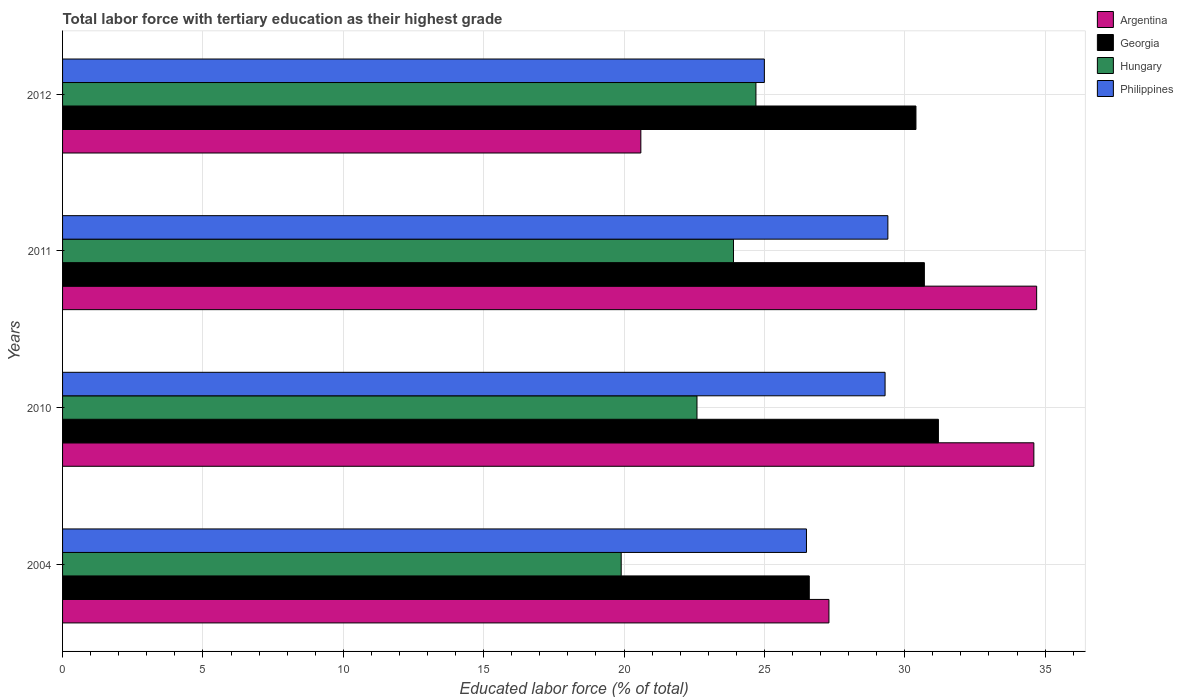How many groups of bars are there?
Your response must be concise. 4. Are the number of bars per tick equal to the number of legend labels?
Keep it short and to the point. Yes. Are the number of bars on each tick of the Y-axis equal?
Your answer should be compact. Yes. How many bars are there on the 1st tick from the bottom?
Your answer should be very brief. 4. What is the label of the 3rd group of bars from the top?
Your answer should be very brief. 2010. In how many cases, is the number of bars for a given year not equal to the number of legend labels?
Make the answer very short. 0. What is the percentage of male labor force with tertiary education in Georgia in 2010?
Your response must be concise. 31.2. Across all years, what is the maximum percentage of male labor force with tertiary education in Hungary?
Ensure brevity in your answer.  24.7. Across all years, what is the minimum percentage of male labor force with tertiary education in Argentina?
Your answer should be very brief. 20.6. In which year was the percentage of male labor force with tertiary education in Georgia maximum?
Offer a terse response. 2010. What is the total percentage of male labor force with tertiary education in Hungary in the graph?
Your answer should be very brief. 91.1. What is the difference between the percentage of male labor force with tertiary education in Hungary in 2004 and that in 2011?
Ensure brevity in your answer.  -4. What is the difference between the percentage of male labor force with tertiary education in Georgia in 2011 and the percentage of male labor force with tertiary education in Philippines in 2012?
Offer a very short reply. 5.7. What is the average percentage of male labor force with tertiary education in Argentina per year?
Your answer should be very brief. 29.3. In the year 2010, what is the difference between the percentage of male labor force with tertiary education in Hungary and percentage of male labor force with tertiary education in Philippines?
Keep it short and to the point. -6.7. In how many years, is the percentage of male labor force with tertiary education in Hungary greater than 5 %?
Keep it short and to the point. 4. What is the ratio of the percentage of male labor force with tertiary education in Georgia in 2004 to that in 2012?
Give a very brief answer. 0.88. What is the difference between the highest and the second highest percentage of male labor force with tertiary education in Hungary?
Offer a terse response. 0.8. What is the difference between the highest and the lowest percentage of male labor force with tertiary education in Georgia?
Offer a terse response. 4.6. What does the 3rd bar from the top in 2010 represents?
Give a very brief answer. Georgia. What does the 2nd bar from the bottom in 2012 represents?
Your answer should be very brief. Georgia. Is it the case that in every year, the sum of the percentage of male labor force with tertiary education in Argentina and percentage of male labor force with tertiary education in Hungary is greater than the percentage of male labor force with tertiary education in Georgia?
Provide a succinct answer. Yes. What is the difference between two consecutive major ticks on the X-axis?
Make the answer very short. 5. Does the graph contain grids?
Offer a terse response. Yes. How many legend labels are there?
Your answer should be compact. 4. How are the legend labels stacked?
Your answer should be very brief. Vertical. What is the title of the graph?
Your answer should be compact. Total labor force with tertiary education as their highest grade. What is the label or title of the X-axis?
Provide a short and direct response. Educated labor force (% of total). What is the label or title of the Y-axis?
Make the answer very short. Years. What is the Educated labor force (% of total) of Argentina in 2004?
Keep it short and to the point. 27.3. What is the Educated labor force (% of total) in Georgia in 2004?
Make the answer very short. 26.6. What is the Educated labor force (% of total) of Hungary in 2004?
Give a very brief answer. 19.9. What is the Educated labor force (% of total) of Argentina in 2010?
Your answer should be compact. 34.6. What is the Educated labor force (% of total) of Georgia in 2010?
Offer a very short reply. 31.2. What is the Educated labor force (% of total) in Hungary in 2010?
Ensure brevity in your answer.  22.6. What is the Educated labor force (% of total) in Philippines in 2010?
Offer a very short reply. 29.3. What is the Educated labor force (% of total) in Argentina in 2011?
Your answer should be compact. 34.7. What is the Educated labor force (% of total) in Georgia in 2011?
Offer a very short reply. 30.7. What is the Educated labor force (% of total) in Hungary in 2011?
Your response must be concise. 23.9. What is the Educated labor force (% of total) in Philippines in 2011?
Keep it short and to the point. 29.4. What is the Educated labor force (% of total) of Argentina in 2012?
Provide a succinct answer. 20.6. What is the Educated labor force (% of total) in Georgia in 2012?
Provide a succinct answer. 30.4. What is the Educated labor force (% of total) in Hungary in 2012?
Your answer should be compact. 24.7. Across all years, what is the maximum Educated labor force (% of total) of Argentina?
Offer a terse response. 34.7. Across all years, what is the maximum Educated labor force (% of total) in Georgia?
Make the answer very short. 31.2. Across all years, what is the maximum Educated labor force (% of total) in Hungary?
Ensure brevity in your answer.  24.7. Across all years, what is the maximum Educated labor force (% of total) in Philippines?
Give a very brief answer. 29.4. Across all years, what is the minimum Educated labor force (% of total) of Argentina?
Provide a succinct answer. 20.6. Across all years, what is the minimum Educated labor force (% of total) in Georgia?
Keep it short and to the point. 26.6. Across all years, what is the minimum Educated labor force (% of total) of Hungary?
Provide a succinct answer. 19.9. Across all years, what is the minimum Educated labor force (% of total) of Philippines?
Offer a very short reply. 25. What is the total Educated labor force (% of total) in Argentina in the graph?
Keep it short and to the point. 117.2. What is the total Educated labor force (% of total) in Georgia in the graph?
Ensure brevity in your answer.  118.9. What is the total Educated labor force (% of total) in Hungary in the graph?
Ensure brevity in your answer.  91.1. What is the total Educated labor force (% of total) of Philippines in the graph?
Provide a short and direct response. 110.2. What is the difference between the Educated labor force (% of total) in Argentina in 2004 and that in 2010?
Offer a terse response. -7.3. What is the difference between the Educated labor force (% of total) of Georgia in 2004 and that in 2010?
Provide a succinct answer. -4.6. What is the difference between the Educated labor force (% of total) in Hungary in 2004 and that in 2010?
Provide a short and direct response. -2.7. What is the difference between the Educated labor force (% of total) of Philippines in 2004 and that in 2010?
Give a very brief answer. -2.8. What is the difference between the Educated labor force (% of total) in Argentina in 2004 and that in 2011?
Keep it short and to the point. -7.4. What is the difference between the Educated labor force (% of total) of Georgia in 2004 and that in 2012?
Offer a terse response. -3.8. What is the difference between the Educated labor force (% of total) of Hungary in 2004 and that in 2012?
Your response must be concise. -4.8. What is the difference between the Educated labor force (% of total) in Georgia in 2010 and that in 2011?
Make the answer very short. 0.5. What is the difference between the Educated labor force (% of total) of Georgia in 2010 and that in 2012?
Provide a succinct answer. 0.8. What is the difference between the Educated labor force (% of total) in Hungary in 2010 and that in 2012?
Offer a very short reply. -2.1. What is the difference between the Educated labor force (% of total) of Philippines in 2011 and that in 2012?
Your answer should be very brief. 4.4. What is the difference between the Educated labor force (% of total) of Georgia in 2004 and the Educated labor force (% of total) of Philippines in 2010?
Make the answer very short. -2.7. What is the difference between the Educated labor force (% of total) of Argentina in 2004 and the Educated labor force (% of total) of Georgia in 2011?
Offer a very short reply. -3.4. What is the difference between the Educated labor force (% of total) in Argentina in 2004 and the Educated labor force (% of total) in Hungary in 2011?
Your answer should be very brief. 3.4. What is the difference between the Educated labor force (% of total) in Argentina in 2004 and the Educated labor force (% of total) in Philippines in 2011?
Give a very brief answer. -2.1. What is the difference between the Educated labor force (% of total) of Georgia in 2004 and the Educated labor force (% of total) of Hungary in 2011?
Ensure brevity in your answer.  2.7. What is the difference between the Educated labor force (% of total) in Georgia in 2004 and the Educated labor force (% of total) in Philippines in 2011?
Keep it short and to the point. -2.8. What is the difference between the Educated labor force (% of total) in Georgia in 2004 and the Educated labor force (% of total) in Philippines in 2012?
Provide a succinct answer. 1.6. What is the difference between the Educated labor force (% of total) in Hungary in 2010 and the Educated labor force (% of total) in Philippines in 2011?
Give a very brief answer. -6.8. What is the difference between the Educated labor force (% of total) in Argentina in 2010 and the Educated labor force (% of total) in Georgia in 2012?
Keep it short and to the point. 4.2. What is the difference between the Educated labor force (% of total) of Argentina in 2010 and the Educated labor force (% of total) of Hungary in 2012?
Make the answer very short. 9.9. What is the difference between the Educated labor force (% of total) in Argentina in 2010 and the Educated labor force (% of total) in Philippines in 2012?
Offer a terse response. 9.6. What is the average Educated labor force (% of total) of Argentina per year?
Keep it short and to the point. 29.3. What is the average Educated labor force (% of total) in Georgia per year?
Your response must be concise. 29.73. What is the average Educated labor force (% of total) of Hungary per year?
Your answer should be compact. 22.77. What is the average Educated labor force (% of total) of Philippines per year?
Give a very brief answer. 27.55. In the year 2004, what is the difference between the Educated labor force (% of total) of Argentina and Educated labor force (% of total) of Hungary?
Keep it short and to the point. 7.4. In the year 2004, what is the difference between the Educated labor force (% of total) in Georgia and Educated labor force (% of total) in Philippines?
Offer a terse response. 0.1. In the year 2010, what is the difference between the Educated labor force (% of total) in Georgia and Educated labor force (% of total) in Philippines?
Make the answer very short. 1.9. In the year 2011, what is the difference between the Educated labor force (% of total) of Argentina and Educated labor force (% of total) of Georgia?
Offer a terse response. 4. In the year 2011, what is the difference between the Educated labor force (% of total) in Argentina and Educated labor force (% of total) in Philippines?
Your response must be concise. 5.3. In the year 2011, what is the difference between the Educated labor force (% of total) in Georgia and Educated labor force (% of total) in Hungary?
Provide a short and direct response. 6.8. In the year 2011, what is the difference between the Educated labor force (% of total) in Georgia and Educated labor force (% of total) in Philippines?
Offer a very short reply. 1.3. In the year 2011, what is the difference between the Educated labor force (% of total) in Hungary and Educated labor force (% of total) in Philippines?
Your answer should be compact. -5.5. In the year 2012, what is the difference between the Educated labor force (% of total) of Argentina and Educated labor force (% of total) of Hungary?
Your response must be concise. -4.1. In the year 2012, what is the difference between the Educated labor force (% of total) in Argentina and Educated labor force (% of total) in Philippines?
Keep it short and to the point. -4.4. What is the ratio of the Educated labor force (% of total) in Argentina in 2004 to that in 2010?
Your answer should be very brief. 0.79. What is the ratio of the Educated labor force (% of total) in Georgia in 2004 to that in 2010?
Offer a very short reply. 0.85. What is the ratio of the Educated labor force (% of total) of Hungary in 2004 to that in 2010?
Offer a very short reply. 0.88. What is the ratio of the Educated labor force (% of total) of Philippines in 2004 to that in 2010?
Provide a short and direct response. 0.9. What is the ratio of the Educated labor force (% of total) in Argentina in 2004 to that in 2011?
Your answer should be compact. 0.79. What is the ratio of the Educated labor force (% of total) of Georgia in 2004 to that in 2011?
Provide a succinct answer. 0.87. What is the ratio of the Educated labor force (% of total) in Hungary in 2004 to that in 2011?
Offer a terse response. 0.83. What is the ratio of the Educated labor force (% of total) of Philippines in 2004 to that in 2011?
Your response must be concise. 0.9. What is the ratio of the Educated labor force (% of total) of Argentina in 2004 to that in 2012?
Provide a short and direct response. 1.33. What is the ratio of the Educated labor force (% of total) of Hungary in 2004 to that in 2012?
Make the answer very short. 0.81. What is the ratio of the Educated labor force (% of total) of Philippines in 2004 to that in 2012?
Your response must be concise. 1.06. What is the ratio of the Educated labor force (% of total) in Georgia in 2010 to that in 2011?
Give a very brief answer. 1.02. What is the ratio of the Educated labor force (% of total) in Hungary in 2010 to that in 2011?
Provide a succinct answer. 0.95. What is the ratio of the Educated labor force (% of total) in Philippines in 2010 to that in 2011?
Offer a very short reply. 1. What is the ratio of the Educated labor force (% of total) in Argentina in 2010 to that in 2012?
Provide a short and direct response. 1.68. What is the ratio of the Educated labor force (% of total) of Georgia in 2010 to that in 2012?
Provide a succinct answer. 1.03. What is the ratio of the Educated labor force (% of total) in Hungary in 2010 to that in 2012?
Give a very brief answer. 0.92. What is the ratio of the Educated labor force (% of total) of Philippines in 2010 to that in 2012?
Provide a succinct answer. 1.17. What is the ratio of the Educated labor force (% of total) of Argentina in 2011 to that in 2012?
Your answer should be very brief. 1.68. What is the ratio of the Educated labor force (% of total) in Georgia in 2011 to that in 2012?
Provide a succinct answer. 1.01. What is the ratio of the Educated labor force (% of total) of Hungary in 2011 to that in 2012?
Give a very brief answer. 0.97. What is the ratio of the Educated labor force (% of total) of Philippines in 2011 to that in 2012?
Give a very brief answer. 1.18. What is the difference between the highest and the second highest Educated labor force (% of total) in Argentina?
Provide a short and direct response. 0.1. What is the difference between the highest and the second highest Educated labor force (% of total) of Hungary?
Keep it short and to the point. 0.8. What is the difference between the highest and the second highest Educated labor force (% of total) in Philippines?
Make the answer very short. 0.1. What is the difference between the highest and the lowest Educated labor force (% of total) in Argentina?
Offer a terse response. 14.1. 